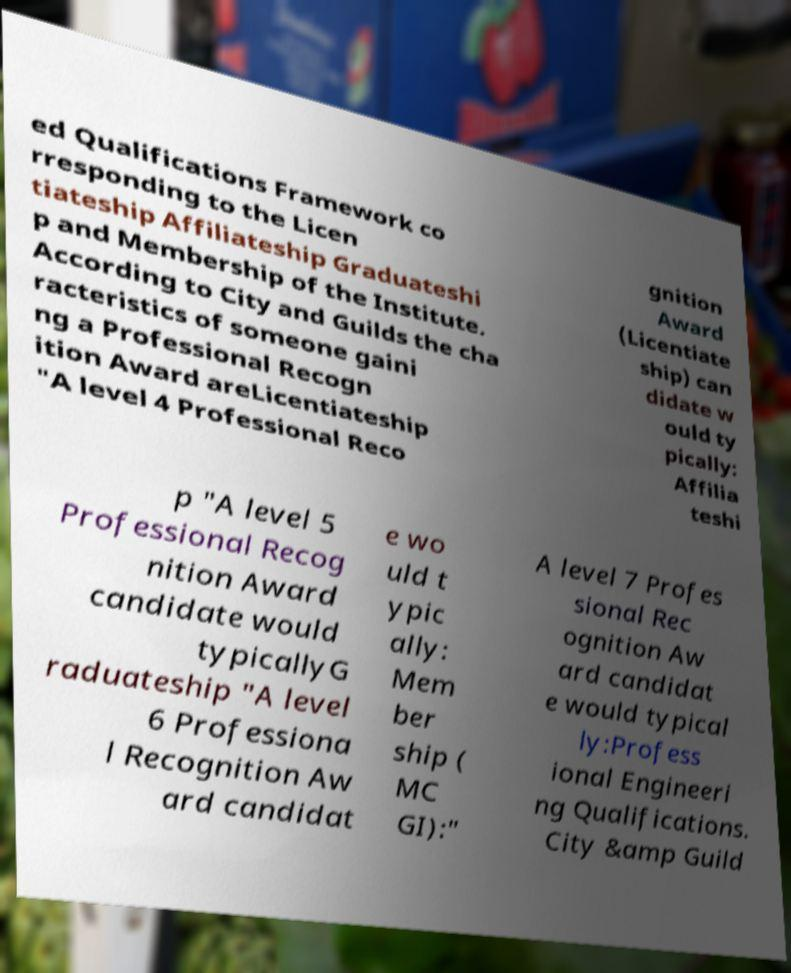I need the written content from this picture converted into text. Can you do that? ed Qualifications Framework co rresponding to the Licen tiateship Affiliateship Graduateshi p and Membership of the Institute. According to City and Guilds the cha racteristics of someone gaini ng a Professional Recogn ition Award areLicentiateship "A level 4 Professional Reco gnition Award (Licentiate ship) can didate w ould ty pically: Affilia teshi p "A level 5 Professional Recog nition Award candidate would typicallyG raduateship "A level 6 Professiona l Recognition Aw ard candidat e wo uld t ypic ally: Mem ber ship ( MC GI):" A level 7 Profes sional Rec ognition Aw ard candidat e would typical ly:Profess ional Engineeri ng Qualifications. City &amp Guild 